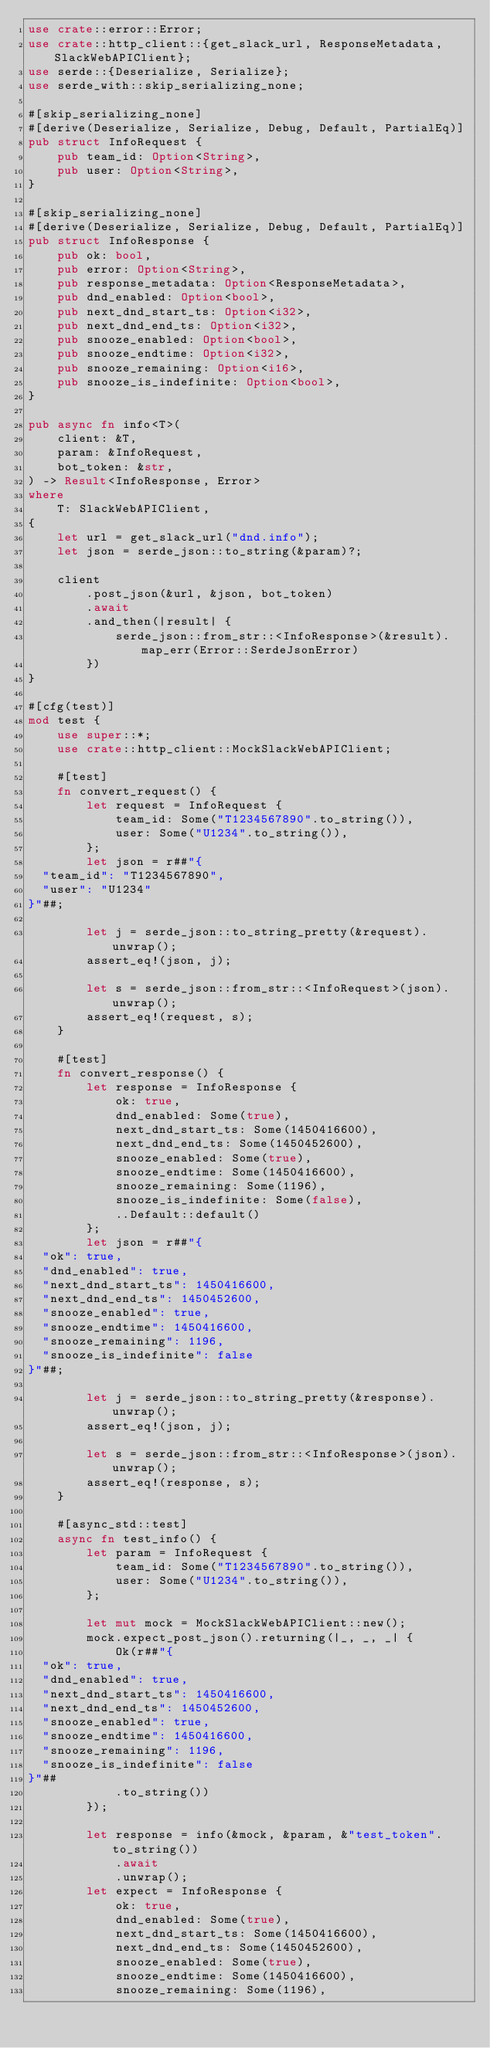Convert code to text. <code><loc_0><loc_0><loc_500><loc_500><_Rust_>use crate::error::Error;
use crate::http_client::{get_slack_url, ResponseMetadata, SlackWebAPIClient};
use serde::{Deserialize, Serialize};
use serde_with::skip_serializing_none;

#[skip_serializing_none]
#[derive(Deserialize, Serialize, Debug, Default, PartialEq)]
pub struct InfoRequest {
    pub team_id: Option<String>,
    pub user: Option<String>,
}

#[skip_serializing_none]
#[derive(Deserialize, Serialize, Debug, Default, PartialEq)]
pub struct InfoResponse {
    pub ok: bool,
    pub error: Option<String>,
    pub response_metadata: Option<ResponseMetadata>,
    pub dnd_enabled: Option<bool>,
    pub next_dnd_start_ts: Option<i32>,
    pub next_dnd_end_ts: Option<i32>,
    pub snooze_enabled: Option<bool>,
    pub snooze_endtime: Option<i32>,
    pub snooze_remaining: Option<i16>,
    pub snooze_is_indefinite: Option<bool>,
}

pub async fn info<T>(
    client: &T,
    param: &InfoRequest,
    bot_token: &str,
) -> Result<InfoResponse, Error>
where
    T: SlackWebAPIClient,
{
    let url = get_slack_url("dnd.info");
    let json = serde_json::to_string(&param)?;

    client
        .post_json(&url, &json, bot_token)
        .await
        .and_then(|result| {
            serde_json::from_str::<InfoResponse>(&result).map_err(Error::SerdeJsonError)
        })
}

#[cfg(test)]
mod test {
    use super::*;
    use crate::http_client::MockSlackWebAPIClient;

    #[test]
    fn convert_request() {
        let request = InfoRequest {
            team_id: Some("T1234567890".to_string()),
            user: Some("U1234".to_string()),
        };
        let json = r##"{
  "team_id": "T1234567890",
  "user": "U1234"
}"##;

        let j = serde_json::to_string_pretty(&request).unwrap();
        assert_eq!(json, j);

        let s = serde_json::from_str::<InfoRequest>(json).unwrap();
        assert_eq!(request, s);
    }

    #[test]
    fn convert_response() {
        let response = InfoResponse {
            ok: true,
            dnd_enabled: Some(true),
            next_dnd_start_ts: Some(1450416600),
            next_dnd_end_ts: Some(1450452600),
            snooze_enabled: Some(true),
            snooze_endtime: Some(1450416600),
            snooze_remaining: Some(1196),
            snooze_is_indefinite: Some(false),
            ..Default::default()
        };
        let json = r##"{
  "ok": true,
  "dnd_enabled": true,
  "next_dnd_start_ts": 1450416600,
  "next_dnd_end_ts": 1450452600,
  "snooze_enabled": true,
  "snooze_endtime": 1450416600,
  "snooze_remaining": 1196,
  "snooze_is_indefinite": false
}"##;

        let j = serde_json::to_string_pretty(&response).unwrap();
        assert_eq!(json, j);

        let s = serde_json::from_str::<InfoResponse>(json).unwrap();
        assert_eq!(response, s);
    }

    #[async_std::test]
    async fn test_info() {
        let param = InfoRequest {
            team_id: Some("T1234567890".to_string()),
            user: Some("U1234".to_string()),
        };

        let mut mock = MockSlackWebAPIClient::new();
        mock.expect_post_json().returning(|_, _, _| {
            Ok(r##"{
  "ok": true,
  "dnd_enabled": true,
  "next_dnd_start_ts": 1450416600,
  "next_dnd_end_ts": 1450452600,
  "snooze_enabled": true,
  "snooze_endtime": 1450416600,
  "snooze_remaining": 1196,
  "snooze_is_indefinite": false
}"##
            .to_string())
        });

        let response = info(&mock, &param, &"test_token".to_string())
            .await
            .unwrap();
        let expect = InfoResponse {
            ok: true,
            dnd_enabled: Some(true),
            next_dnd_start_ts: Some(1450416600),
            next_dnd_end_ts: Some(1450452600),
            snooze_enabled: Some(true),
            snooze_endtime: Some(1450416600),
            snooze_remaining: Some(1196),</code> 